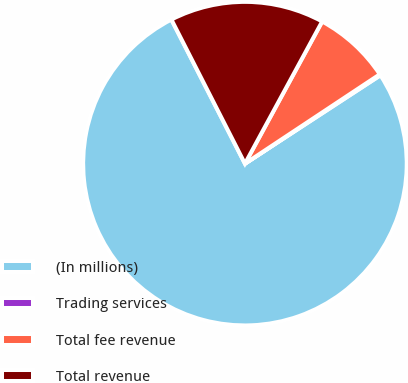Convert chart to OTSL. <chart><loc_0><loc_0><loc_500><loc_500><pie_chart><fcel>(In millions)<fcel>Trading services<fcel>Total fee revenue<fcel>Total revenue<nl><fcel>76.69%<fcel>0.11%<fcel>7.77%<fcel>15.43%<nl></chart> 